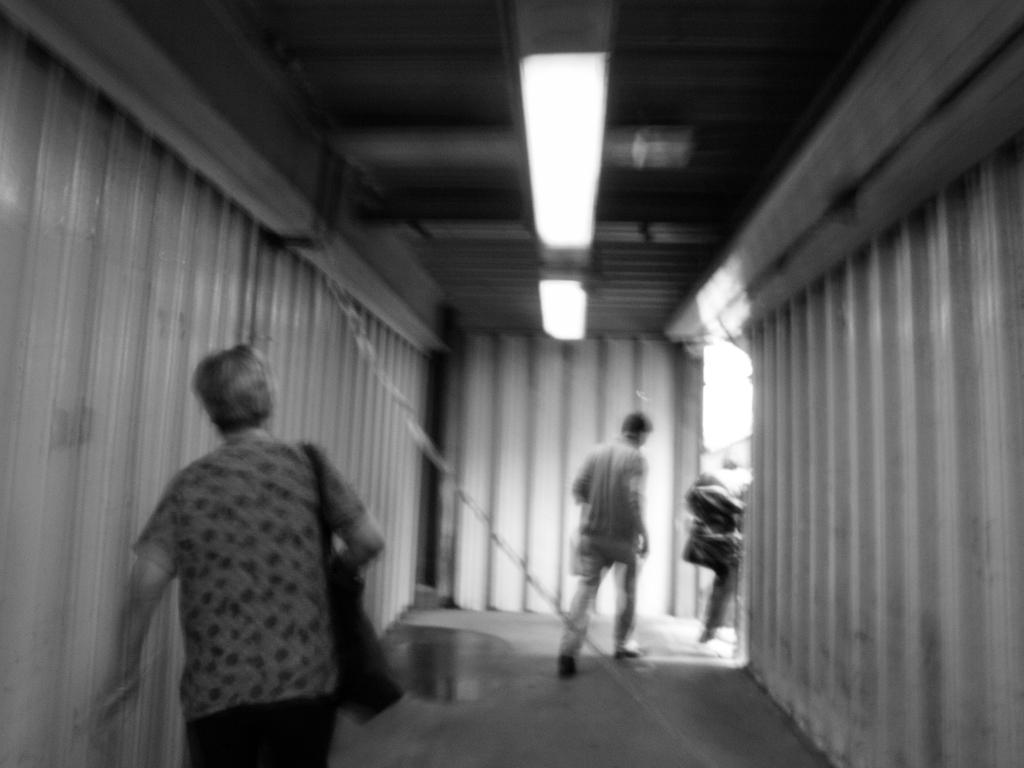In one or two sentences, can you explain what this image depicts? It is the black and white image in which there are few people walking on the floor inside the tunnel. At the top there are lights. At the bottom there is some water on the floor. 